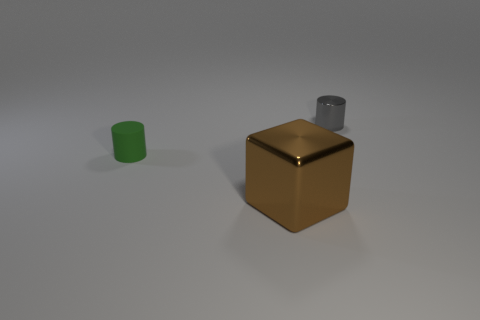Add 3 small gray objects. How many objects exist? 6 Subtract all blocks. How many objects are left? 2 Subtract all large cyan shiny cylinders. Subtract all small rubber objects. How many objects are left? 2 Add 2 large metal things. How many large metal things are left? 3 Add 3 tiny gray metallic objects. How many tiny gray metallic objects exist? 4 Subtract 0 yellow cylinders. How many objects are left? 3 